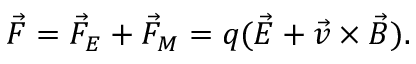<formula> <loc_0><loc_0><loc_500><loc_500>\ V e c { F } = \ V e c { F } _ { E } + \ V e c { F } _ { M } = q ( \ V e c { E } + \vec { v } \times \ V e c { B } ) .</formula> 